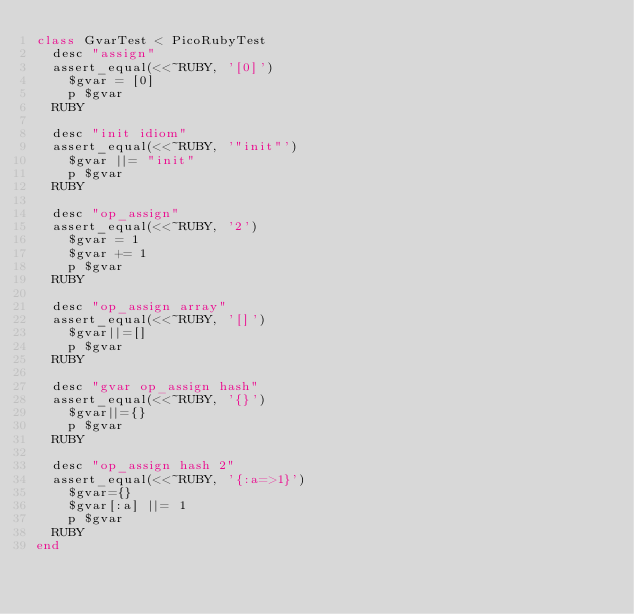<code> <loc_0><loc_0><loc_500><loc_500><_Ruby_>class GvarTest < PicoRubyTest
  desc "assign"
  assert_equal(<<~RUBY, '[0]')
    $gvar = [0]
    p $gvar
  RUBY

  desc "init idiom"
  assert_equal(<<~RUBY, '"init"')
    $gvar ||= "init"
    p $gvar
  RUBY

  desc "op_assign"
  assert_equal(<<~RUBY, '2')
    $gvar = 1
    $gvar += 1
    p $gvar
  RUBY

  desc "op_assign array"
  assert_equal(<<~RUBY, '[]')
    $gvar||=[]
    p $gvar
  RUBY

  desc "gvar op_assign hash"
  assert_equal(<<~RUBY, '{}')
    $gvar||={}
    p $gvar
  RUBY

  desc "op_assign hash 2"
  assert_equal(<<~RUBY, '{:a=>1}')
    $gvar={}
    $gvar[:a] ||= 1
    p $gvar
  RUBY
end
</code> 